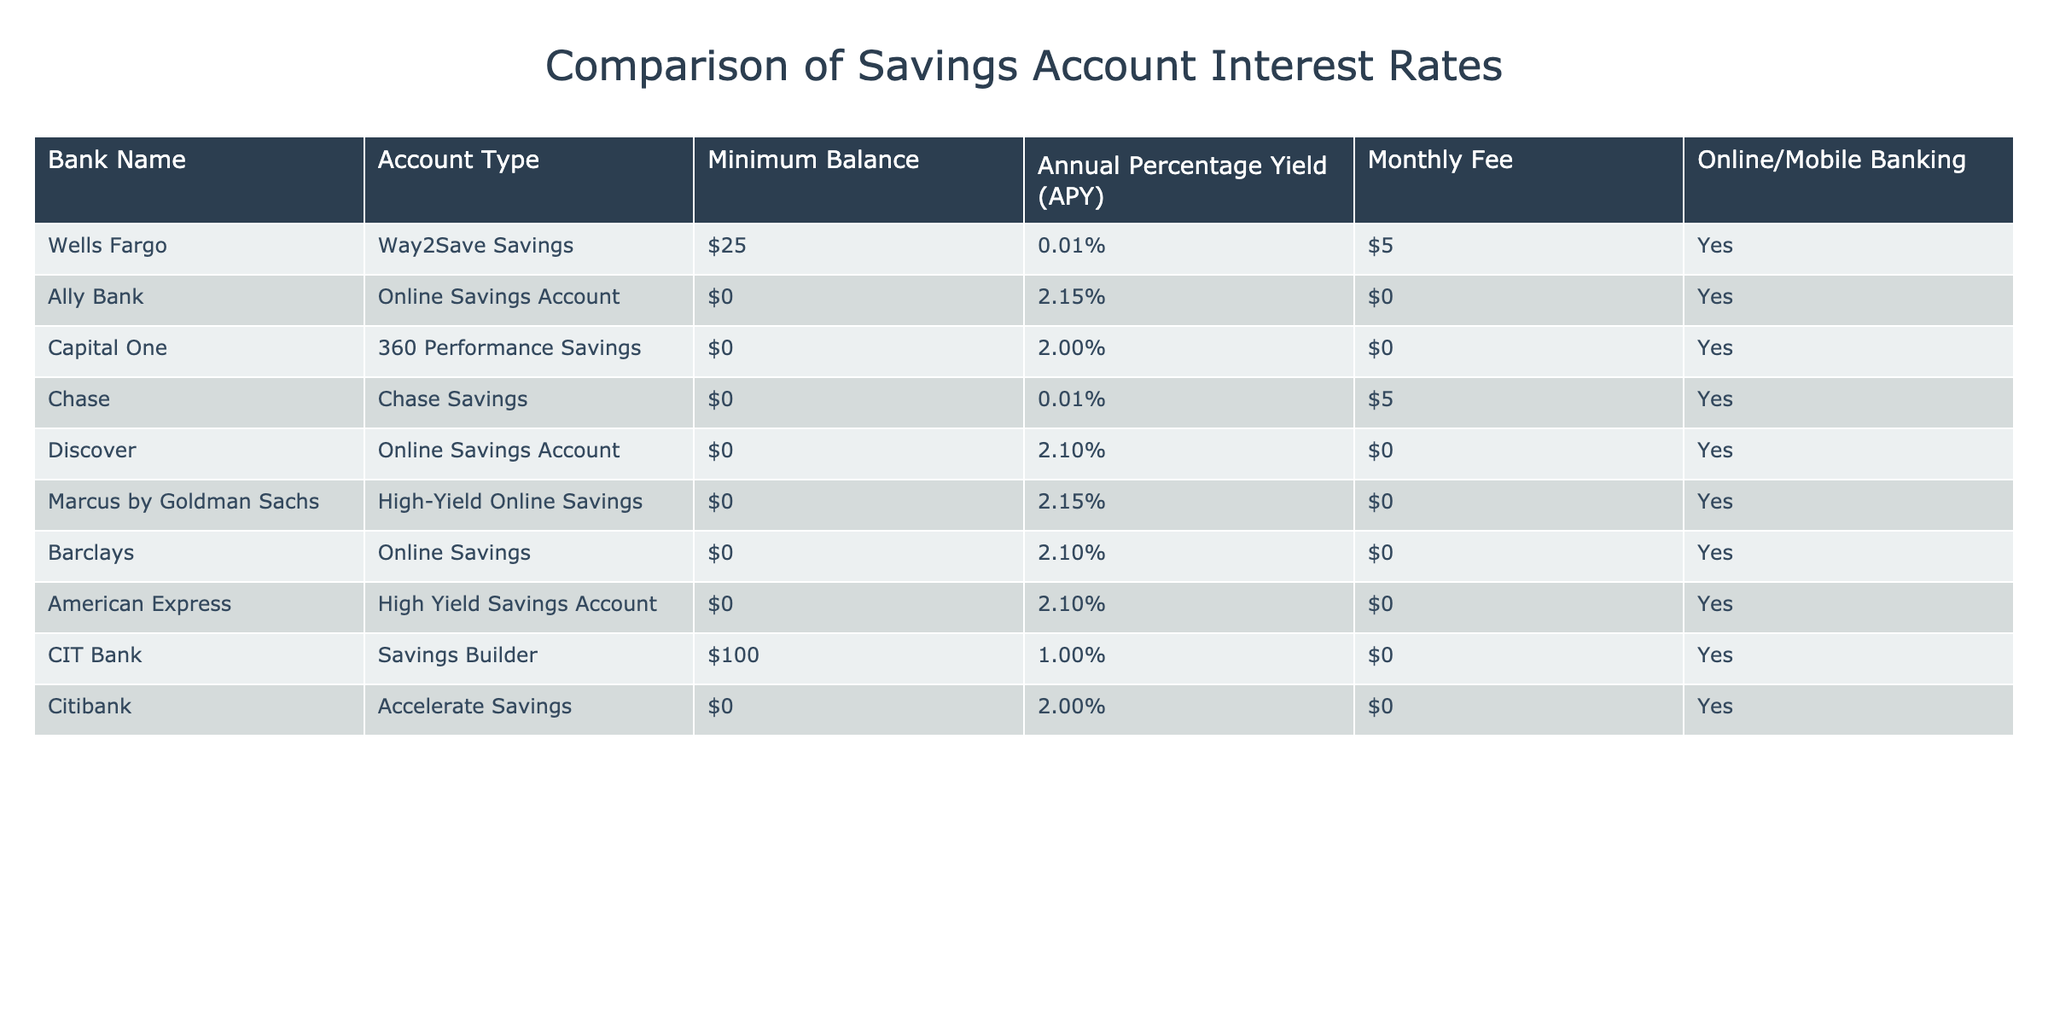What is the highest Annual Percentage Yield (APY) among the bank accounts listed? The table shows that Ally Bank and Marcus by Goldman Sachs have the highest APY, which is 2.15%.
Answer: 2.15% Which bank offers an account with the lowest minimum balance? The table indicates that both Ally Bank and Capital One offer savings accounts with a minimum balance of $0.
Answer: $0 Do any banks charge a monthly fee for their savings accounts? According to the table, Wells Fargo and Chase charge a monthly fee of $5 for their accounts.
Answer: Yes What is the difference in APY between the highest and lowest rates offered? The highest APY is 2.15% (from Ally Bank and Marcus by Goldman Sachs) and the lowest is 0.01% (from Wells Fargo and Chase), so the difference is 2.15% - 0.01% = 2.14%.
Answer: 2.14% Which account types do not require a minimum balance? The table indicates that the following accounts do not require a minimum balance: Ally Bank, Capital One, Chase, Discover, Marcus by Goldman Sachs, Barclays, American Express, and Citibank.
Answer: 8 accounts Is online or mobile banking available for all banks listed? Yes, the table shows that all banks listed offer online or mobile banking for their savings accounts.
Answer: Yes What is the average APY of the accounts that do not charge a monthly fee? The APYs for accounts with no monthly fee are 2.15% (Ally Bank), 2.00% (Capital One), 2.10% (Discover), 2.15% (Marcus by Goldman Sachs), 2.10% (Barclays), 2.10% (American Express), and 2.00% (Citibank). Adding these gives 14.75%, and dividing by 7 accounts results in an average of approximately 2.11%.
Answer: 2.11% How many banks offer savings accounts with an APY of 2.10% or higher? The table shows that there are five banks with an APY of 2.10% or higher: Ally Bank, Discover, Marcus by Goldman Sachs, Barclays, and American Express.
Answer: 5 banks What is the total amount of minimum balance required if someone wants to open accounts at all banks listed? The minimum balances required are $25 (Wells Fargo), $0 (Ally Bank), $0 (Capital One), $0 (Chase), $0 (Discover), $0 (Marcus by Goldman Sachs), $0 (Barclays), $0 (American Express), and $100 (CIT Bank). Summing these gives $25 + $100 = $125.
Answer: $125 Which bank has the highest minimum balance requirement? According to the table, CIT Bank has the highest minimum balance requirement of $100.
Answer: $100 